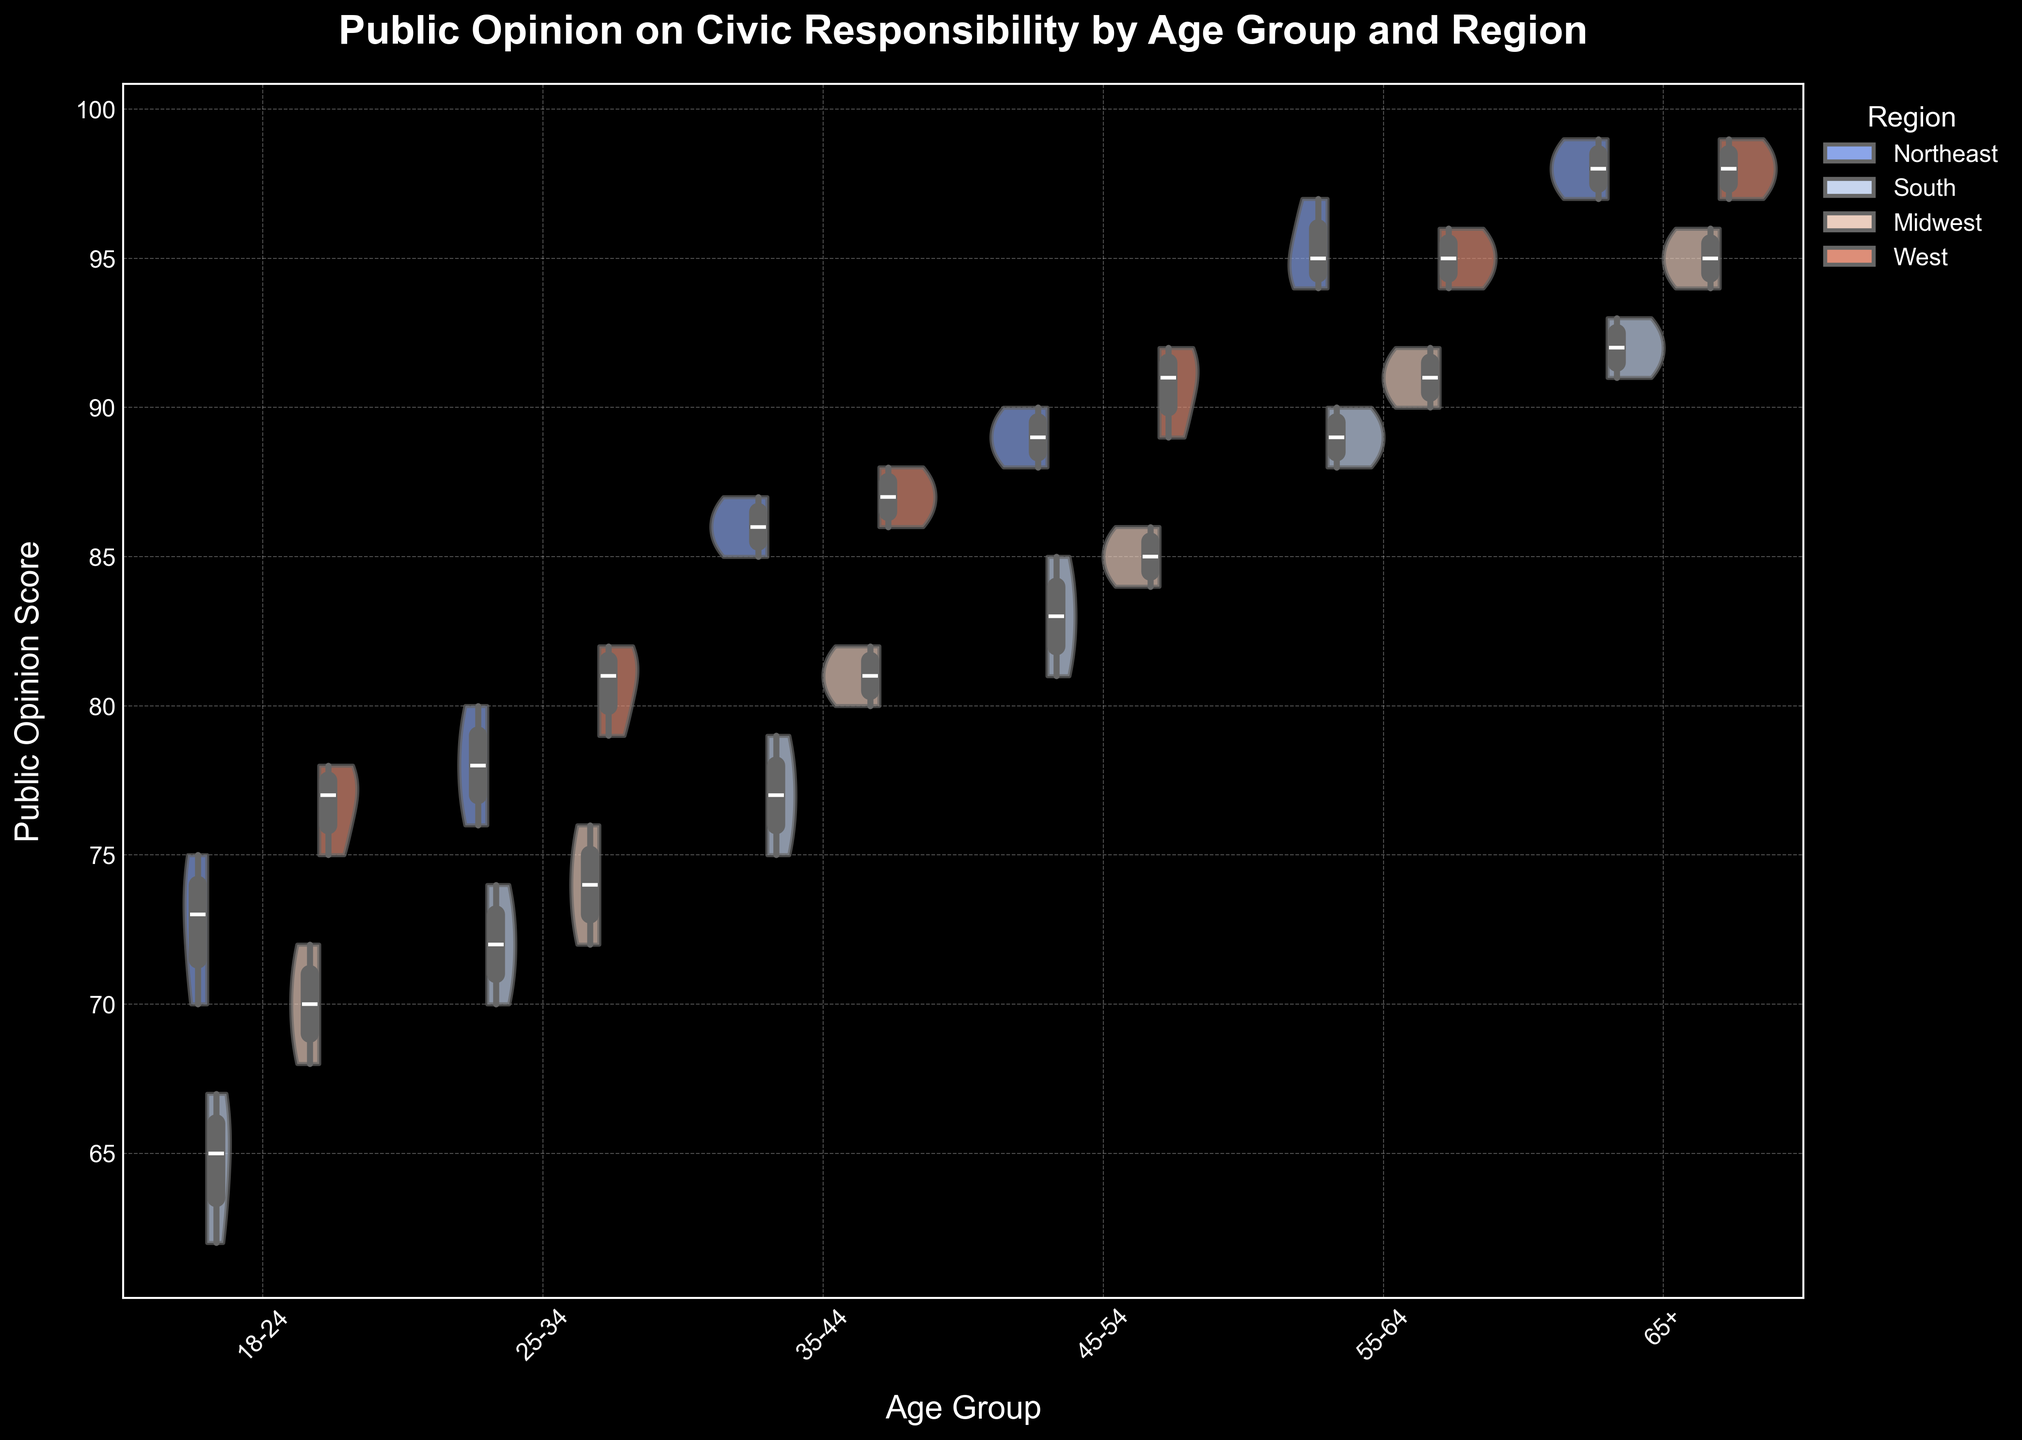What is the title of the figure? The title is prominently displayed at the top of the figure. It describes the subject of the visualization.
Answer: Public Opinion on Civic Responsibility by Age Group and Region What age group has the highest public opinion scores in general? By examining the distribution of the scores in each age group, the 65+ age group appears to have the highest public opinion scores overall.
Answer: 65+ Which region shows the greatest variation in public opinion scores for the 18-24 age group? The width and spread of the violin plot for each region in the 18-24 age group indicate the variation. The South region shows the greatest variation.
Answer: South Which age group in the Northeast region has the least variation in public opinion scores? By comparing the widths of the violin plots for each age group in the Northeast region, the 55-64 age group has the least variation.
Answer: 55-64 Which region tends to have higher public opinion scores for the 45-54 age group? By comparing the median lines in the box plots for each region within the 45-54 age group, the West region tends to have higher scores.
Answer: West How do public opinion scores for the 25-34 age group in the West compare to those in the South? The median and spread of the scores can be compared using the box plots. The West region has a higher median score and less variation than the South.
Answer: The West region scores higher Is there a noticeable trend in public opinion scores as age increases for the Northeast region? By examining the progression of the median lines in the box plots for the Northeast region across age groups, there is a noticeable upward trend as age increases.
Answer: Yes, an upward trend For the 35-44 age group, which region shows the least variation in public opinion scores? The width of the violin plot for each region in the 35-44 age group indicates the variation. The Northeast region shows the least variation.
Answer: Northeast Which two age groups in the Midwest have almost similar median public opinion scores? By looking at the black median lines in the box plots, the 25-34 and 35-44 age groups in the Midwest have almost similar medians.
Answer: 25-34 and 35-44 What's the range of public opinion scores for the 55-64 age group in the South? The range can be determined by the highest and lowest points of the violin/box plot for the South region within the 55-64 age group. The range is from 88 to 90.
Answer: 88 to 90 